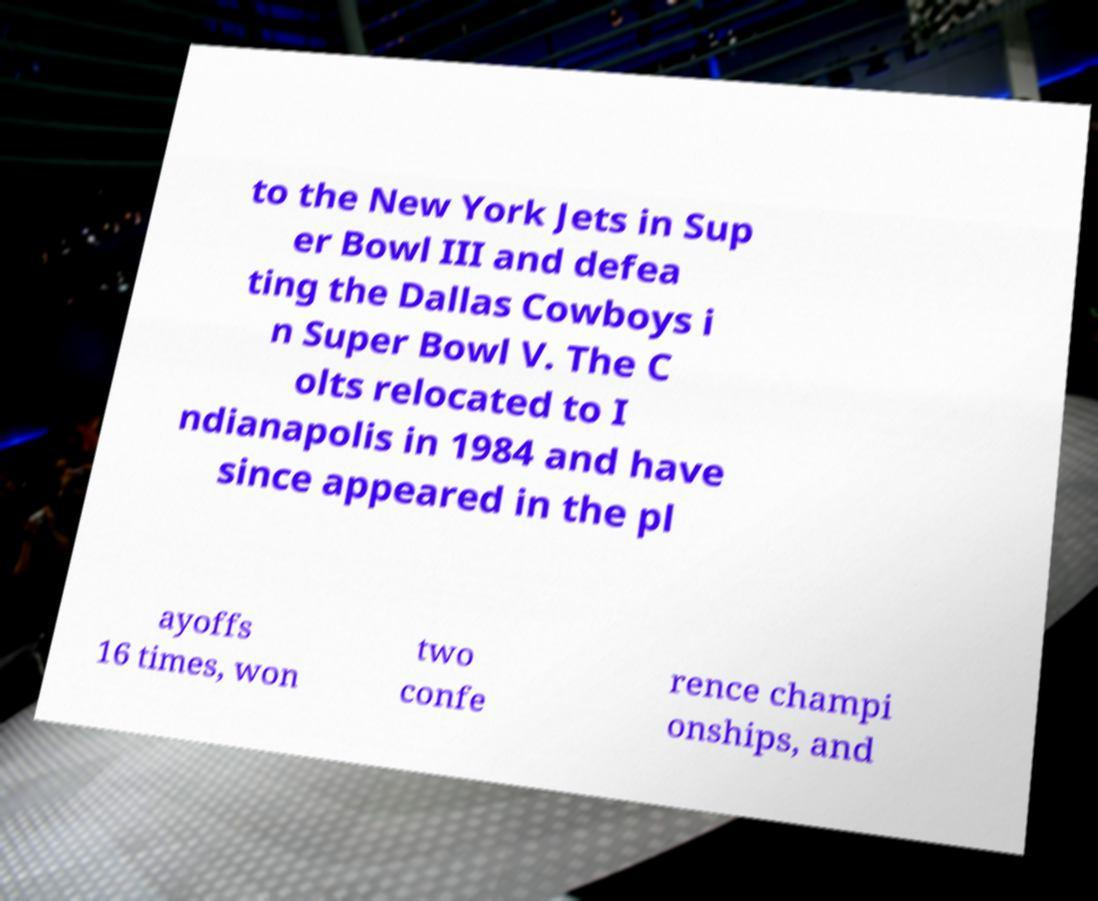Can you accurately transcribe the text from the provided image for me? to the New York Jets in Sup er Bowl III and defea ting the Dallas Cowboys i n Super Bowl V. The C olts relocated to I ndianapolis in 1984 and have since appeared in the pl ayoffs 16 times, won two confe rence champi onships, and 